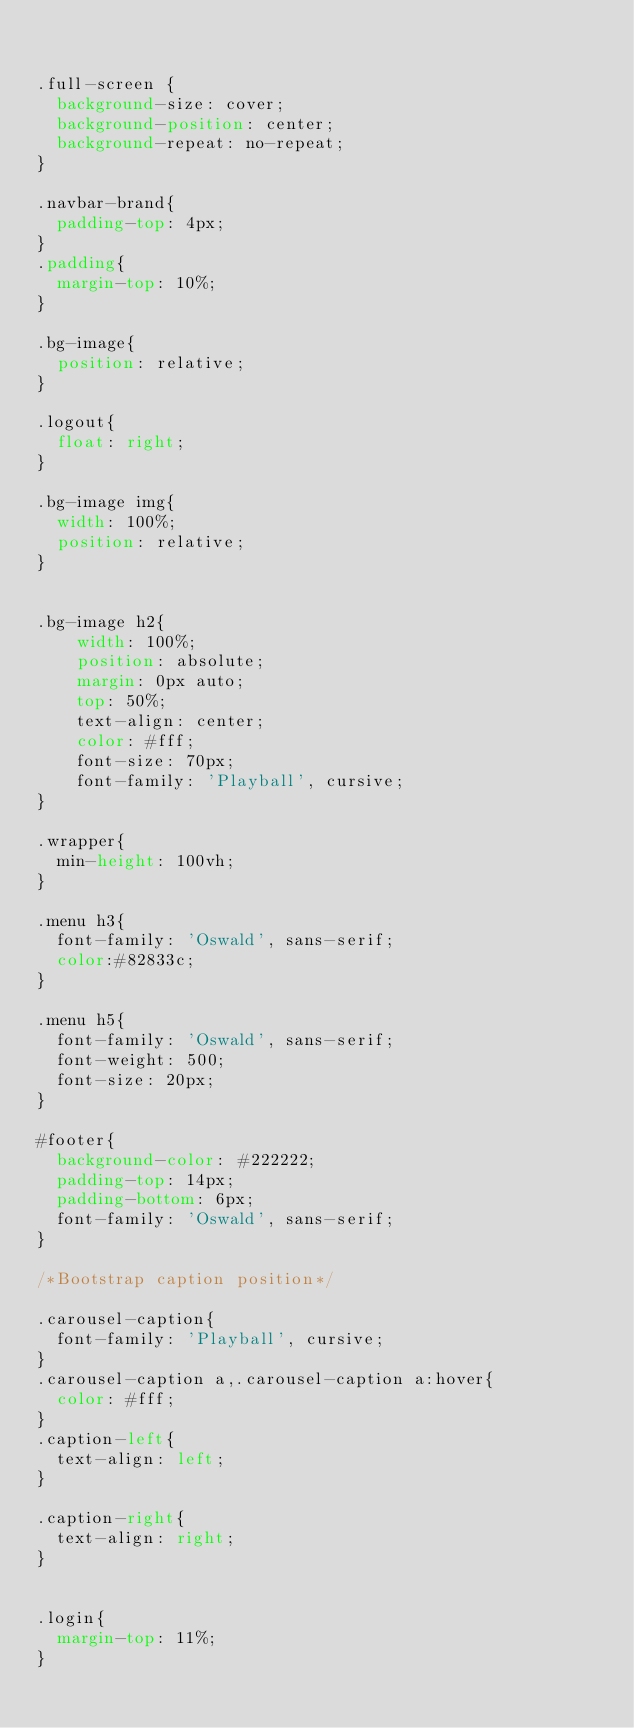Convert code to text. <code><loc_0><loc_0><loc_500><loc_500><_CSS_>

.full-screen {
  background-size: cover;
  background-position: center;
  background-repeat: no-repeat;
}

.navbar-brand{
  padding-top: 4px;
}
.padding{
  margin-top: 10%;
}

.bg-image{
  position: relative;
}

.logout{
  float: right;
}

.bg-image img{
  width: 100%;
  position: relative;
}


.bg-image h2{
    width: 100%;
    position: absolute;
    margin: 0px auto;
    top: 50%;
    text-align: center;
    color: #fff;
    font-size: 70px;
    font-family: 'Playball', cursive;
}

.wrapper{
  min-height: 100vh;
}

.menu h3{
  font-family: 'Oswald', sans-serif;
  color:#82833c;
}

.menu h5{
  font-family: 'Oswald', sans-serif;
  font-weight: 500;
  font-size: 20px;
}

#footer{
  background-color: #222222;
  padding-top: 14px;
  padding-bottom: 6px;
  font-family: 'Oswald', sans-serif;
}

/*Bootstrap caption position*/

.carousel-caption{
  font-family: 'Playball', cursive;
}
.carousel-caption a,.carousel-caption a:hover{
  color: #fff;
}
.caption-left{
  text-align: left;
}

.caption-right{
  text-align: right;
}


.login{
  margin-top: 11%;
}
</code> 